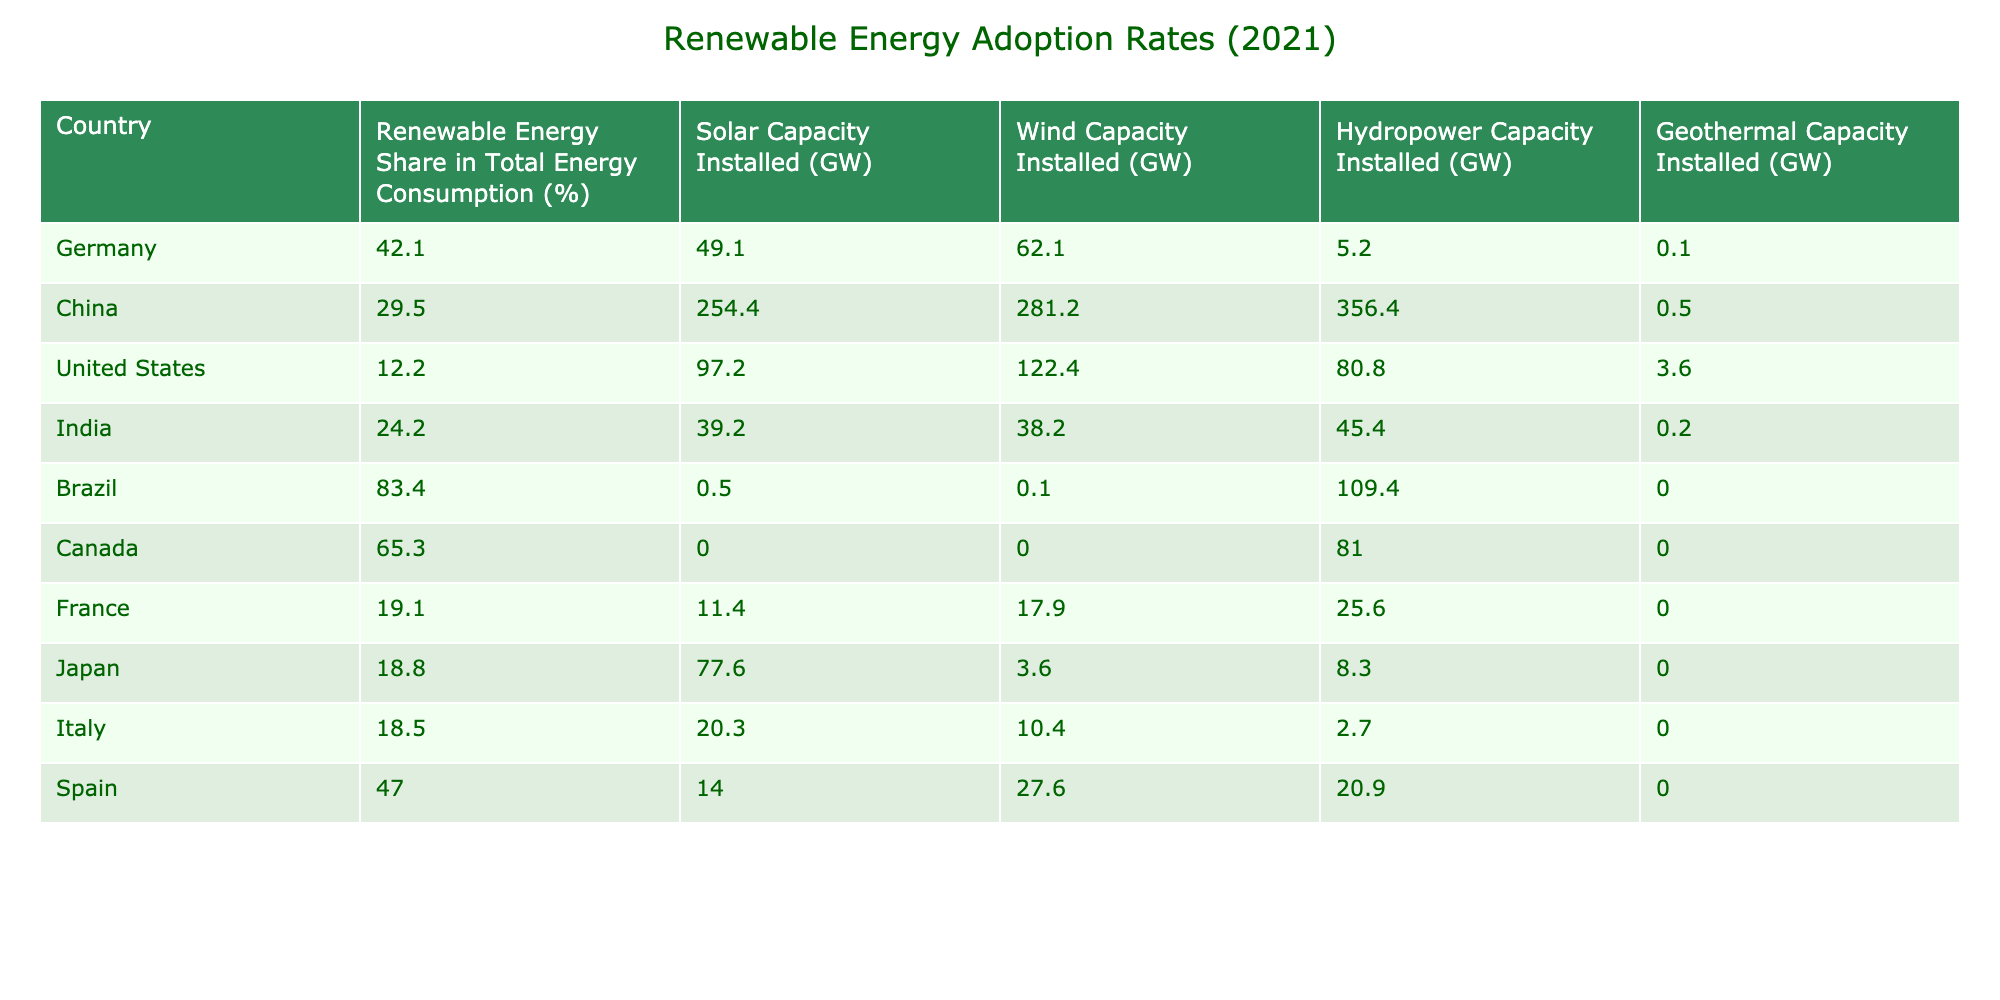What country had the highest share of renewable energy in total energy consumption in 2021? By examining the column for "Renewable Energy Share in Total Energy Consumption (%)", Brazil has the highest percentage at 83.4%.
Answer: Brazil What is the total installed capacity of solar energy in China? Referring to the "Solar Capacity Installed (GW)" column, China has a total installed capacity of 254.4 GW.
Answer: 254.4 GW Which country has the lowest renewable energy share in total energy consumption? Looking at the renewable energy share percentages, the United States has the lowest share at 12.2%.
Answer: United States Calculate the average hydropower capacity installed for the top three countries with the highest renewable energy share. The top three countries are Brazil (109.4 GW), Canada (81.0 GW), and Germany (5.2 GW). Summing these gives 109.4 + 81.0 + 5.2 = 195.6 GW, and dividing by 3 gives 195.6 / 3 = 65.2 GW.
Answer: 65.2 GW Is it true that Japan has a higher solar capacity installed than Italy? Japan has 77.6 GW of solar capacity installed, while Italy has only 20.3 GW. Therefore, the statement is true.
Answer: Yes How much more wind capacity is installed in Germany compared to India? Germany has 62.1 GW and India has 38.2 GW in wind capacity installed. The difference is 62.1 - 38.2 = 23.9 GW more in Germany.
Answer: 23.9 GW Which country has a higher total installed capacity for geothermal energy, China or the United States? From the table, China has 0.5 GW while the United States has 3.6 GW installed for geothermal energy. Therefore, the United States has a higher capacity.
Answer: United States What is the total installed capacity of renewable energy for Germany? Summing all the capacities installed for Germany: solar (49.1 GW) + wind (62.1 GW) + hydropower (5.2 GW) + geothermal (0.1 GW) gives 49.1 + 62.1 + 5.2 + 0.1 = 116.5 GW.
Answer: 116.5 GW Which country leads in total installed wind capacity? China has the highest installed wind capacity at 281.2 GW according to the "Wind Capacity Installed (GW)" column, significantly more than any other country in the table.
Answer: China 